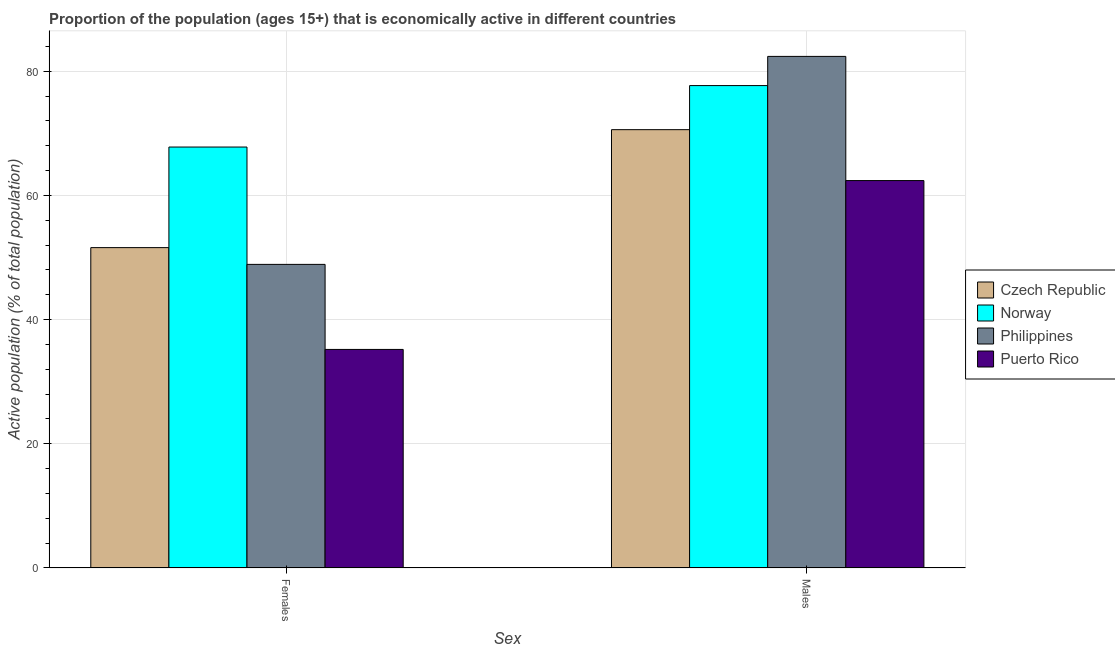How many groups of bars are there?
Provide a succinct answer. 2. Are the number of bars per tick equal to the number of legend labels?
Offer a very short reply. Yes. Are the number of bars on each tick of the X-axis equal?
Provide a short and direct response. Yes. What is the label of the 1st group of bars from the left?
Your answer should be very brief. Females. What is the percentage of economically active male population in Puerto Rico?
Make the answer very short. 62.4. Across all countries, what is the maximum percentage of economically active male population?
Offer a terse response. 82.4. Across all countries, what is the minimum percentage of economically active male population?
Your answer should be compact. 62.4. In which country was the percentage of economically active female population maximum?
Ensure brevity in your answer.  Norway. In which country was the percentage of economically active male population minimum?
Offer a very short reply. Puerto Rico. What is the total percentage of economically active female population in the graph?
Provide a short and direct response. 203.5. What is the difference between the percentage of economically active female population in Norway and that in Philippines?
Ensure brevity in your answer.  18.9. What is the difference between the percentage of economically active female population in Norway and the percentage of economically active male population in Philippines?
Offer a terse response. -14.6. What is the average percentage of economically active male population per country?
Offer a very short reply. 73.27. What is the difference between the percentage of economically active female population and percentage of economically active male population in Norway?
Provide a succinct answer. -9.9. What is the ratio of the percentage of economically active male population in Czech Republic to that in Puerto Rico?
Offer a very short reply. 1.13. In how many countries, is the percentage of economically active male population greater than the average percentage of economically active male population taken over all countries?
Give a very brief answer. 2. What does the 4th bar from the right in Males represents?
Make the answer very short. Czech Republic. How many bars are there?
Ensure brevity in your answer.  8. Are all the bars in the graph horizontal?
Your answer should be compact. No. How many countries are there in the graph?
Make the answer very short. 4. What is the difference between two consecutive major ticks on the Y-axis?
Provide a short and direct response. 20. Does the graph contain grids?
Your answer should be compact. Yes. How are the legend labels stacked?
Provide a short and direct response. Vertical. What is the title of the graph?
Ensure brevity in your answer.  Proportion of the population (ages 15+) that is economically active in different countries. Does "Syrian Arab Republic" appear as one of the legend labels in the graph?
Offer a very short reply. No. What is the label or title of the X-axis?
Ensure brevity in your answer.  Sex. What is the label or title of the Y-axis?
Make the answer very short. Active population (% of total population). What is the Active population (% of total population) of Czech Republic in Females?
Provide a succinct answer. 51.6. What is the Active population (% of total population) of Norway in Females?
Ensure brevity in your answer.  67.8. What is the Active population (% of total population) of Philippines in Females?
Your answer should be compact. 48.9. What is the Active population (% of total population) in Puerto Rico in Females?
Make the answer very short. 35.2. What is the Active population (% of total population) of Czech Republic in Males?
Ensure brevity in your answer.  70.6. What is the Active population (% of total population) of Norway in Males?
Your response must be concise. 77.7. What is the Active population (% of total population) of Philippines in Males?
Ensure brevity in your answer.  82.4. What is the Active population (% of total population) in Puerto Rico in Males?
Your answer should be compact. 62.4. Across all Sex, what is the maximum Active population (% of total population) in Czech Republic?
Provide a succinct answer. 70.6. Across all Sex, what is the maximum Active population (% of total population) in Norway?
Your response must be concise. 77.7. Across all Sex, what is the maximum Active population (% of total population) in Philippines?
Offer a terse response. 82.4. Across all Sex, what is the maximum Active population (% of total population) in Puerto Rico?
Provide a succinct answer. 62.4. Across all Sex, what is the minimum Active population (% of total population) of Czech Republic?
Provide a succinct answer. 51.6. Across all Sex, what is the minimum Active population (% of total population) in Norway?
Your answer should be very brief. 67.8. Across all Sex, what is the minimum Active population (% of total population) of Philippines?
Provide a succinct answer. 48.9. Across all Sex, what is the minimum Active population (% of total population) in Puerto Rico?
Your response must be concise. 35.2. What is the total Active population (% of total population) of Czech Republic in the graph?
Ensure brevity in your answer.  122.2. What is the total Active population (% of total population) in Norway in the graph?
Your answer should be very brief. 145.5. What is the total Active population (% of total population) of Philippines in the graph?
Provide a short and direct response. 131.3. What is the total Active population (% of total population) in Puerto Rico in the graph?
Keep it short and to the point. 97.6. What is the difference between the Active population (% of total population) of Norway in Females and that in Males?
Offer a very short reply. -9.9. What is the difference between the Active population (% of total population) in Philippines in Females and that in Males?
Ensure brevity in your answer.  -33.5. What is the difference between the Active population (% of total population) in Puerto Rico in Females and that in Males?
Your response must be concise. -27.2. What is the difference between the Active population (% of total population) of Czech Republic in Females and the Active population (% of total population) of Norway in Males?
Your answer should be compact. -26.1. What is the difference between the Active population (% of total population) in Czech Republic in Females and the Active population (% of total population) in Philippines in Males?
Your answer should be very brief. -30.8. What is the difference between the Active population (% of total population) in Norway in Females and the Active population (% of total population) in Philippines in Males?
Offer a terse response. -14.6. What is the difference between the Active population (% of total population) of Norway in Females and the Active population (% of total population) of Puerto Rico in Males?
Give a very brief answer. 5.4. What is the difference between the Active population (% of total population) in Philippines in Females and the Active population (% of total population) in Puerto Rico in Males?
Give a very brief answer. -13.5. What is the average Active population (% of total population) in Czech Republic per Sex?
Your answer should be very brief. 61.1. What is the average Active population (% of total population) of Norway per Sex?
Give a very brief answer. 72.75. What is the average Active population (% of total population) of Philippines per Sex?
Your answer should be very brief. 65.65. What is the average Active population (% of total population) of Puerto Rico per Sex?
Your answer should be very brief. 48.8. What is the difference between the Active population (% of total population) in Czech Republic and Active population (% of total population) in Norway in Females?
Your response must be concise. -16.2. What is the difference between the Active population (% of total population) of Czech Republic and Active population (% of total population) of Philippines in Females?
Keep it short and to the point. 2.7. What is the difference between the Active population (% of total population) of Czech Republic and Active population (% of total population) of Puerto Rico in Females?
Offer a terse response. 16.4. What is the difference between the Active population (% of total population) of Norway and Active population (% of total population) of Philippines in Females?
Ensure brevity in your answer.  18.9. What is the difference between the Active population (% of total population) in Norway and Active population (% of total population) in Puerto Rico in Females?
Offer a terse response. 32.6. What is the difference between the Active population (% of total population) of Philippines and Active population (% of total population) of Puerto Rico in Females?
Give a very brief answer. 13.7. What is the difference between the Active population (% of total population) in Czech Republic and Active population (% of total population) in Norway in Males?
Give a very brief answer. -7.1. What is the difference between the Active population (% of total population) of Czech Republic and Active population (% of total population) of Philippines in Males?
Your answer should be very brief. -11.8. What is the difference between the Active population (% of total population) in Czech Republic and Active population (% of total population) in Puerto Rico in Males?
Your response must be concise. 8.2. What is the difference between the Active population (% of total population) in Norway and Active population (% of total population) in Philippines in Males?
Ensure brevity in your answer.  -4.7. What is the difference between the Active population (% of total population) in Philippines and Active population (% of total population) in Puerto Rico in Males?
Your response must be concise. 20. What is the ratio of the Active population (% of total population) in Czech Republic in Females to that in Males?
Make the answer very short. 0.73. What is the ratio of the Active population (% of total population) of Norway in Females to that in Males?
Your answer should be compact. 0.87. What is the ratio of the Active population (% of total population) of Philippines in Females to that in Males?
Keep it short and to the point. 0.59. What is the ratio of the Active population (% of total population) of Puerto Rico in Females to that in Males?
Make the answer very short. 0.56. What is the difference between the highest and the second highest Active population (% of total population) in Czech Republic?
Make the answer very short. 19. What is the difference between the highest and the second highest Active population (% of total population) of Norway?
Make the answer very short. 9.9. What is the difference between the highest and the second highest Active population (% of total population) in Philippines?
Provide a short and direct response. 33.5. What is the difference between the highest and the second highest Active population (% of total population) in Puerto Rico?
Your response must be concise. 27.2. What is the difference between the highest and the lowest Active population (% of total population) of Czech Republic?
Offer a very short reply. 19. What is the difference between the highest and the lowest Active population (% of total population) in Philippines?
Provide a short and direct response. 33.5. What is the difference between the highest and the lowest Active population (% of total population) of Puerto Rico?
Ensure brevity in your answer.  27.2. 